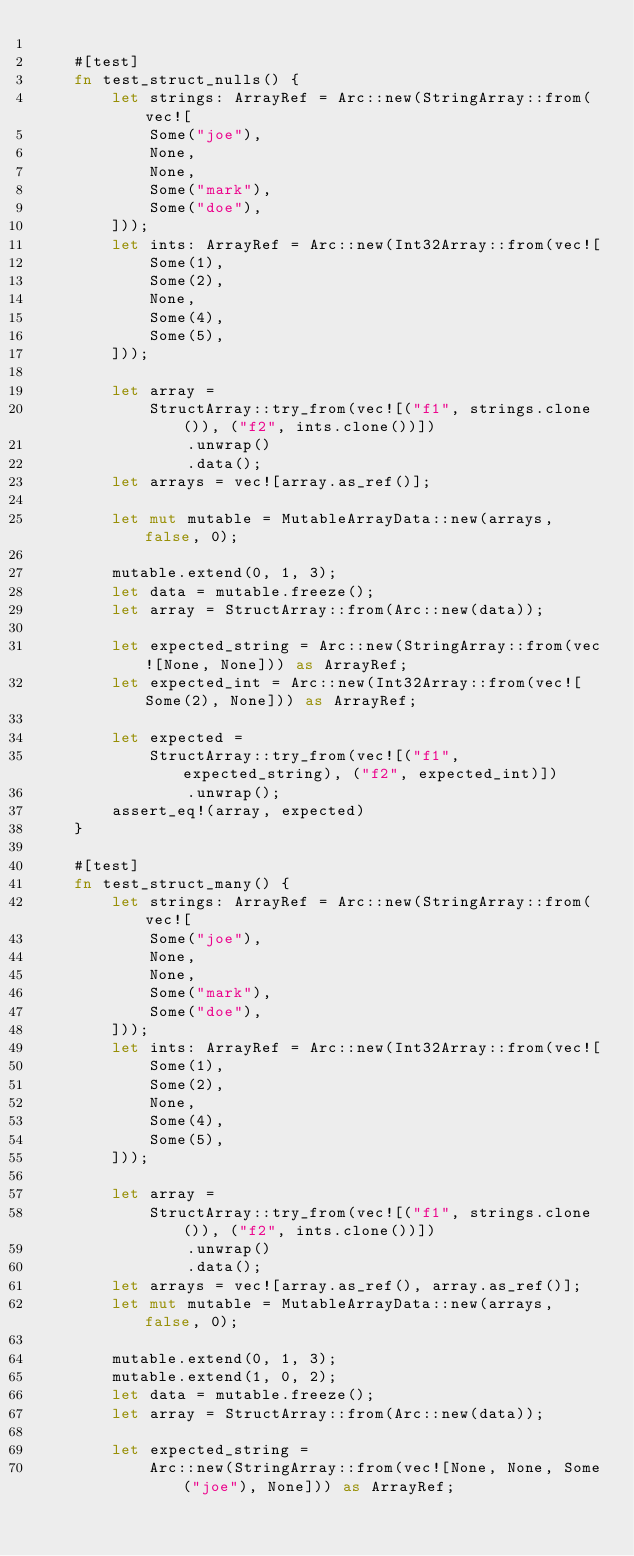Convert code to text. <code><loc_0><loc_0><loc_500><loc_500><_Rust_>
    #[test]
    fn test_struct_nulls() {
        let strings: ArrayRef = Arc::new(StringArray::from(vec![
            Some("joe"),
            None,
            None,
            Some("mark"),
            Some("doe"),
        ]));
        let ints: ArrayRef = Arc::new(Int32Array::from(vec![
            Some(1),
            Some(2),
            None,
            Some(4),
            Some(5),
        ]));

        let array =
            StructArray::try_from(vec![("f1", strings.clone()), ("f2", ints.clone())])
                .unwrap()
                .data();
        let arrays = vec![array.as_ref()];

        let mut mutable = MutableArrayData::new(arrays, false, 0);

        mutable.extend(0, 1, 3);
        let data = mutable.freeze();
        let array = StructArray::from(Arc::new(data));

        let expected_string = Arc::new(StringArray::from(vec![None, None])) as ArrayRef;
        let expected_int = Arc::new(Int32Array::from(vec![Some(2), None])) as ArrayRef;

        let expected =
            StructArray::try_from(vec![("f1", expected_string), ("f2", expected_int)])
                .unwrap();
        assert_eq!(array, expected)
    }

    #[test]
    fn test_struct_many() {
        let strings: ArrayRef = Arc::new(StringArray::from(vec![
            Some("joe"),
            None,
            None,
            Some("mark"),
            Some("doe"),
        ]));
        let ints: ArrayRef = Arc::new(Int32Array::from(vec![
            Some(1),
            Some(2),
            None,
            Some(4),
            Some(5),
        ]));

        let array =
            StructArray::try_from(vec![("f1", strings.clone()), ("f2", ints.clone())])
                .unwrap()
                .data();
        let arrays = vec![array.as_ref(), array.as_ref()];
        let mut mutable = MutableArrayData::new(arrays, false, 0);

        mutable.extend(0, 1, 3);
        mutable.extend(1, 0, 2);
        let data = mutable.freeze();
        let array = StructArray::from(Arc::new(data));

        let expected_string =
            Arc::new(StringArray::from(vec![None, None, Some("joe"), None])) as ArrayRef;</code> 